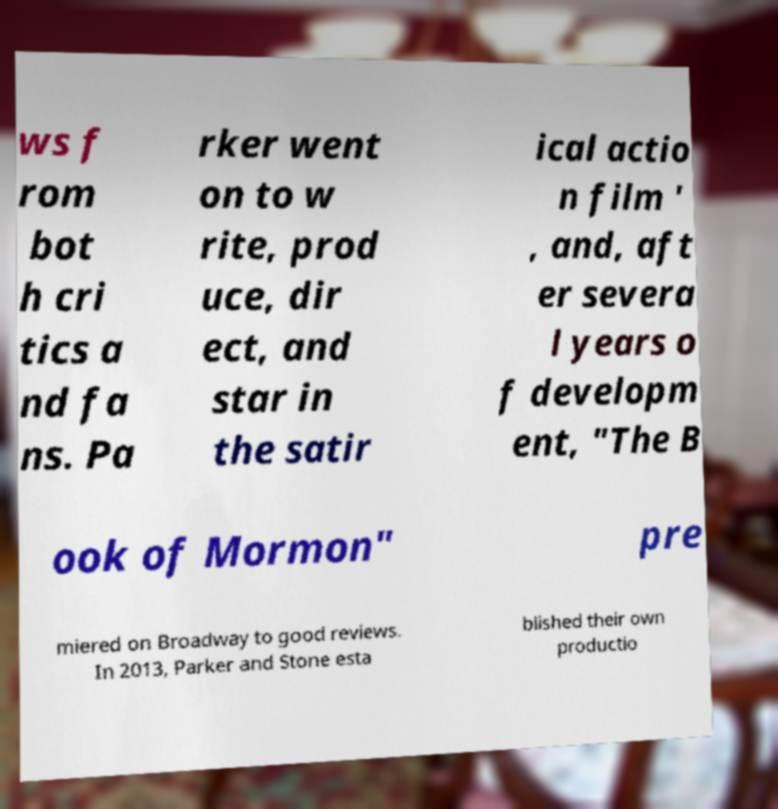Could you assist in decoding the text presented in this image and type it out clearly? ws f rom bot h cri tics a nd fa ns. Pa rker went on to w rite, prod uce, dir ect, and star in the satir ical actio n film ' , and, aft er severa l years o f developm ent, "The B ook of Mormon" pre miered on Broadway to good reviews. In 2013, Parker and Stone esta blished their own productio 